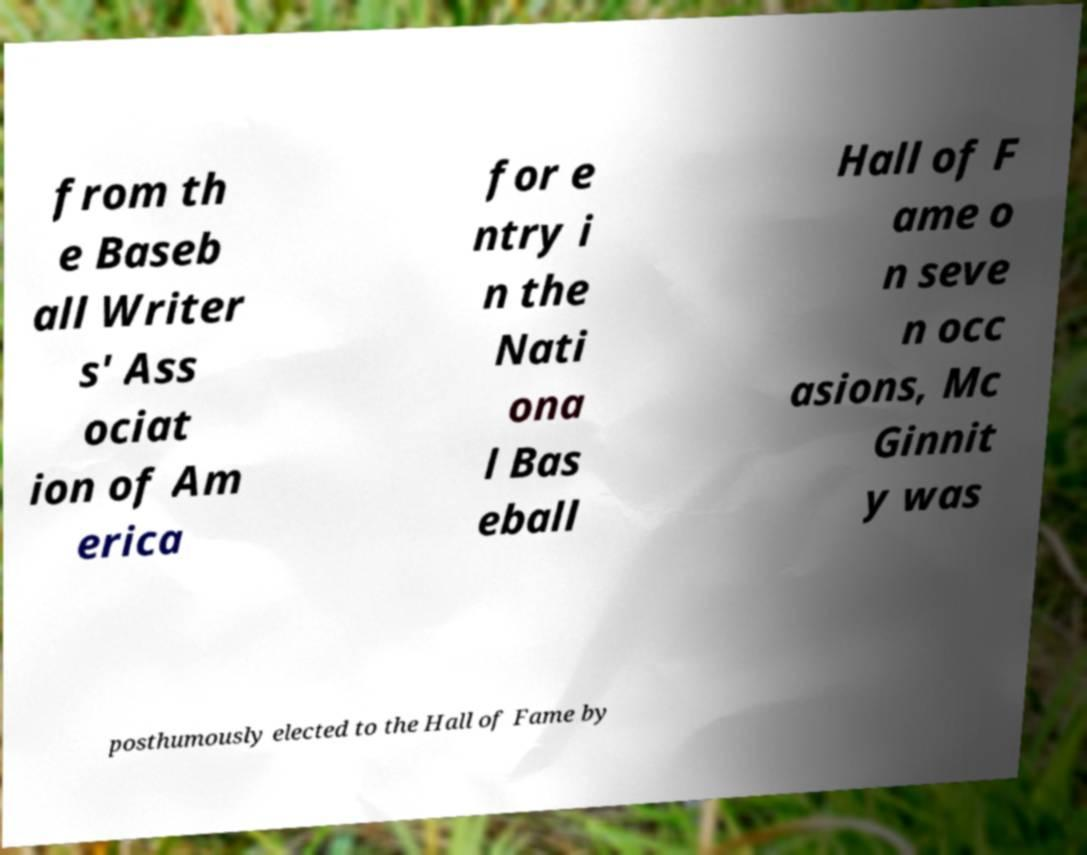What messages or text are displayed in this image? I need them in a readable, typed format. from th e Baseb all Writer s' Ass ociat ion of Am erica for e ntry i n the Nati ona l Bas eball Hall of F ame o n seve n occ asions, Mc Ginnit y was posthumously elected to the Hall of Fame by 